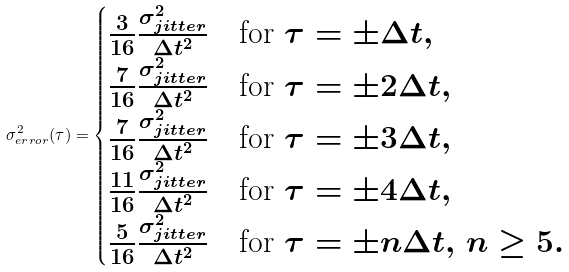Convert formula to latex. <formula><loc_0><loc_0><loc_500><loc_500>\sigma ^ { 2 } _ { e r r o r } ( \tau ) = \begin{cases} \frac { 3 } { 1 6 } \frac { \sigma _ { j i t t e r } ^ { 2 } } { \Delta t ^ { 2 } } & \text {for $\tau=\pm \Delta t$} , \\ \frac { 7 } { 1 6 } \frac { \sigma _ { j i t t e r } ^ { 2 } } { \Delta t ^ { 2 } } & \text {for $\tau=\pm 2\Delta t$} , \\ \frac { 7 } { 1 6 } \frac { \sigma _ { j i t t e r } ^ { 2 } } { \Delta t ^ { 2 } } & \text {for $\tau=\pm 3\Delta t$} , \\ \frac { 1 1 } { 1 6 } \frac { \sigma _ { j i t t e r } ^ { 2 } } { \Delta t ^ { 2 } } & \text {for $\tau=\pm 4\Delta t$} , \\ \frac { 5 } { 1 6 } \frac { \sigma _ { j i t t e r } ^ { 2 } } { \Delta t ^ { 2 } } & \text {for $\tau =\pm n\Delta t,$ $n \geq 5$} . \\ \end{cases}</formula> 